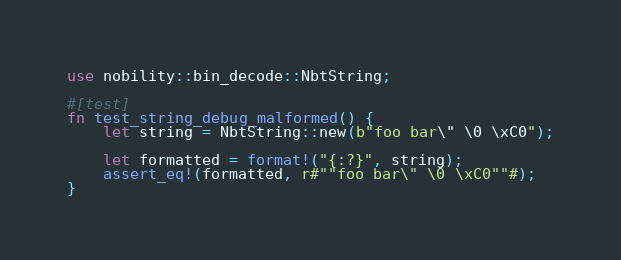Convert code to text. <code><loc_0><loc_0><loc_500><loc_500><_Rust_>use nobility::bin_decode::NbtString;

#[test]
fn test_string_debug_malformed() {
    let string = NbtString::new(b"foo bar\" \0 \xC0");

    let formatted = format!("{:?}", string);
    assert_eq!(formatted, r#""foo bar\" \0 \xC0""#);
}
</code> 